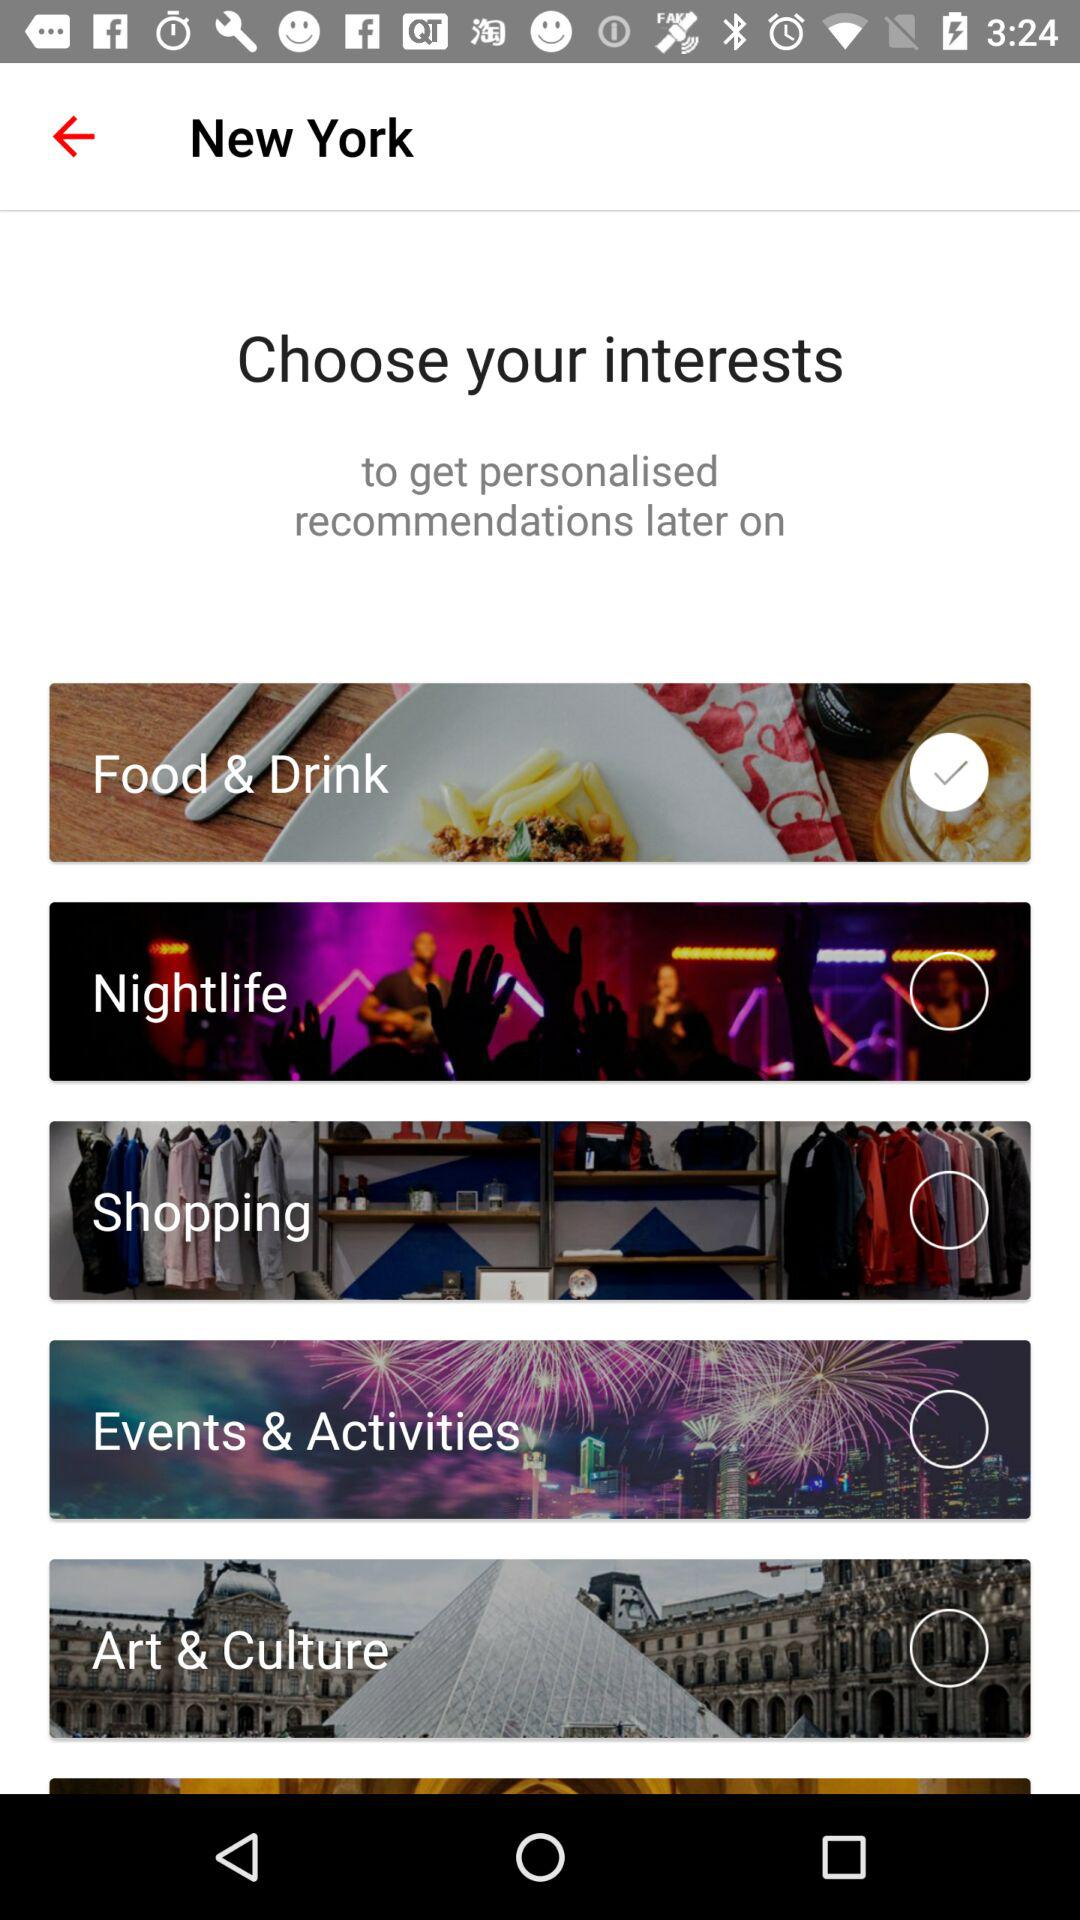Which interest has been selected? The selected interest is "Food & Drink". 